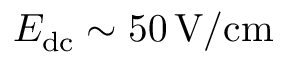<formula> <loc_0><loc_0><loc_500><loc_500>E _ { d c } \sim 5 0 \, V / c m</formula> 